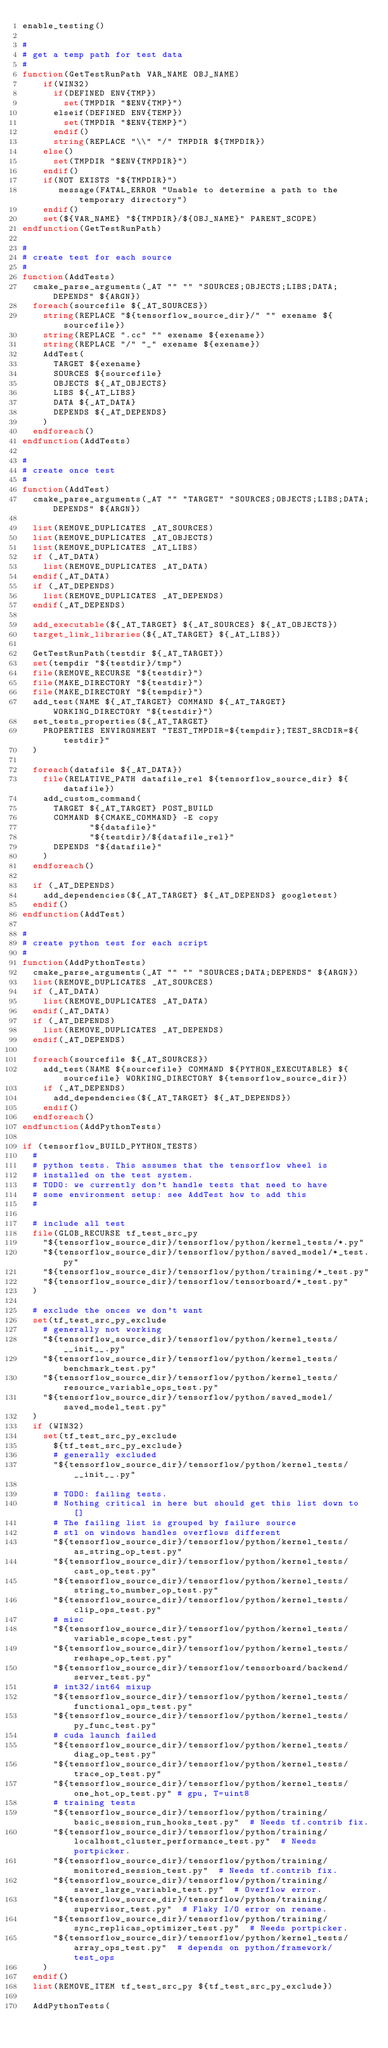<code> <loc_0><loc_0><loc_500><loc_500><_CMake_>enable_testing()

#
# get a temp path for test data
#
function(GetTestRunPath VAR_NAME OBJ_NAME)
    if(WIN32)
      if(DEFINED ENV{TMP})
        set(TMPDIR "$ENV{TMP}")
      elseif(DEFINED ENV{TEMP})
        set(TMPDIR "$ENV{TEMP}")
      endif()
      string(REPLACE "\\" "/" TMPDIR ${TMPDIR})
    else()
      set(TMPDIR "$ENV{TMPDIR}")
    endif()
    if(NOT EXISTS "${TMPDIR}")
       message(FATAL_ERROR "Unable to determine a path to the temporary directory")
    endif()
    set(${VAR_NAME} "${TMPDIR}/${OBJ_NAME}" PARENT_SCOPE)
endfunction(GetTestRunPath)

#
# create test for each source
#
function(AddTests)
  cmake_parse_arguments(_AT "" "" "SOURCES;OBJECTS;LIBS;DATA;DEPENDS" ${ARGN})
  foreach(sourcefile ${_AT_SOURCES})
    string(REPLACE "${tensorflow_source_dir}/" "" exename ${sourcefile})
    string(REPLACE ".cc" "" exename ${exename})
    string(REPLACE "/" "_" exename ${exename})
    AddTest(
      TARGET ${exename}
      SOURCES ${sourcefile}
      OBJECTS ${_AT_OBJECTS}
      LIBS ${_AT_LIBS}
      DATA ${_AT_DATA}
      DEPENDS ${_AT_DEPENDS}
    )
  endforeach()
endfunction(AddTests)

#
# create once test
#
function(AddTest)
  cmake_parse_arguments(_AT "" "TARGET" "SOURCES;OBJECTS;LIBS;DATA;DEPENDS" ${ARGN})

  list(REMOVE_DUPLICATES _AT_SOURCES)
  list(REMOVE_DUPLICATES _AT_OBJECTS)
  list(REMOVE_DUPLICATES _AT_LIBS)
  if (_AT_DATA)
    list(REMOVE_DUPLICATES _AT_DATA)
  endif(_AT_DATA)
  if (_AT_DEPENDS)
    list(REMOVE_DUPLICATES _AT_DEPENDS)
  endif(_AT_DEPENDS)

  add_executable(${_AT_TARGET} ${_AT_SOURCES} ${_AT_OBJECTS})
  target_link_libraries(${_AT_TARGET} ${_AT_LIBS})

  GetTestRunPath(testdir ${_AT_TARGET})
  set(tempdir "${testdir}/tmp")
  file(REMOVE_RECURSE "${testdir}")
  file(MAKE_DIRECTORY "${testdir}")
  file(MAKE_DIRECTORY "${tempdir}")
  add_test(NAME ${_AT_TARGET} COMMAND ${_AT_TARGET} WORKING_DIRECTORY "${testdir}")
  set_tests_properties(${_AT_TARGET}
    PROPERTIES ENVIRONMENT "TEST_TMPDIR=${tempdir};TEST_SRCDIR=${testdir}"
  )

  foreach(datafile ${_AT_DATA})
    file(RELATIVE_PATH datafile_rel ${tensorflow_source_dir} ${datafile})
    add_custom_command(
      TARGET ${_AT_TARGET} POST_BUILD
      COMMAND ${CMAKE_COMMAND} -E copy
             "${datafile}"
             "${testdir}/${datafile_rel}"
      DEPENDS "${datafile}"
    )
  endforeach()

  if (_AT_DEPENDS)
    add_dependencies(${_AT_TARGET} ${_AT_DEPENDS} googletest)
  endif()
endfunction(AddTest)

#
# create python test for each script
#
function(AddPythonTests)
  cmake_parse_arguments(_AT "" "" "SOURCES;DATA;DEPENDS" ${ARGN})
  list(REMOVE_DUPLICATES _AT_SOURCES)
  if (_AT_DATA)
    list(REMOVE_DUPLICATES _AT_DATA)
  endif(_AT_DATA)
  if (_AT_DEPENDS)
    list(REMOVE_DUPLICATES _AT_DEPENDS)
  endif(_AT_DEPENDS)

  foreach(sourcefile ${_AT_SOURCES})
    add_test(NAME ${sourcefile} COMMAND ${PYTHON_EXECUTABLE} ${sourcefile} WORKING_DIRECTORY ${tensorflow_source_dir})
    if (_AT_DEPENDS)
      add_dependencies(${_AT_TARGET} ${_AT_DEPENDS})
    endif()
  endforeach()
endfunction(AddPythonTests)

if (tensorflow_BUILD_PYTHON_TESTS)
  #
  # python tests. This assumes that the tensorflow wheel is
  # installed on the test system.
  # TODO: we currently don't handle tests that need to have
  # some environment setup: see AddTest how to add this
  #

  # include all test
  file(GLOB_RECURSE tf_test_src_py
    "${tensorflow_source_dir}/tensorflow/python/kernel_tests/*.py"
    "${tensorflow_source_dir}/tensorflow/python/saved_model/*_test.py"
    "${tensorflow_source_dir}/tensorflow/python/training/*_test.py"
    "${tensorflow_source_dir}/tensorflow/tensorboard/*_test.py"
  )

  # exclude the onces we don't want
  set(tf_test_src_py_exclude
    # generally not working
    "${tensorflow_source_dir}/tensorflow/python/kernel_tests/__init__.py"
    "${tensorflow_source_dir}/tensorflow/python/kernel_tests/benchmark_test.py"
    "${tensorflow_source_dir}/tensorflow/python/kernel_tests/resource_variable_ops_test.py"
    "${tensorflow_source_dir}/tensorflow/python/saved_model/saved_model_test.py"
  )
  if (WIN32)
    set(tf_test_src_py_exclude
      ${tf_test_src_py_exclude}
      # generally excluded
      "${tensorflow_source_dir}/tensorflow/python/kernel_tests/__init__.py"

      # TODO: failing tests.
      # Nothing critical in here but should get this list down to []
      # The failing list is grouped by failure source
      # stl on windows handles overflows different
      "${tensorflow_source_dir}/tensorflow/python/kernel_tests/as_string_op_test.py"
      "${tensorflow_source_dir}/tensorflow/python/kernel_tests/cast_op_test.py"
      "${tensorflow_source_dir}/tensorflow/python/kernel_tests/string_to_number_op_test.py"
      "${tensorflow_source_dir}/tensorflow/python/kernel_tests/clip_ops_test.py"
      # misc
      "${tensorflow_source_dir}/tensorflow/python/kernel_tests/variable_scope_test.py"
      "${tensorflow_source_dir}/tensorflow/python/kernel_tests/reshape_op_test.py"
      "${tensorflow_source_dir}/tensorflow/tensorboard/backend/server_test.py"
      # int32/int64 mixup
      "${tensorflow_source_dir}/tensorflow/python/kernel_tests/functional_ops_test.py"
      "${tensorflow_source_dir}/tensorflow/python/kernel_tests/py_func_test.py"
      # cuda launch failed
      "${tensorflow_source_dir}/tensorflow/python/kernel_tests/diag_op_test.py"
      "${tensorflow_source_dir}/tensorflow/python/kernel_tests/trace_op_test.py"
      "${tensorflow_source_dir}/tensorflow/python/kernel_tests/one_hot_op_test.py" # gpu, T=uint8
      # training tests
      "${tensorflow_source_dir}/tensorflow/python/training/basic_session_run_hooks_test.py"  # Needs tf.contrib fix.
      "${tensorflow_source_dir}/tensorflow/python/training/localhost_cluster_performance_test.py"  # Needs portpicker.
      "${tensorflow_source_dir}/tensorflow/python/training/monitored_session_test.py"  # Needs tf.contrib fix.
      "${tensorflow_source_dir}/tensorflow/python/training/saver_large_variable_test.py"  # Overflow error.
      "${tensorflow_source_dir}/tensorflow/python/training/supervisor_test.py"  # Flaky I/O error on rename.
      "${tensorflow_source_dir}/tensorflow/python/training/sync_replicas_optimizer_test.py"  # Needs portpicker.
      "${tensorflow_source_dir}/tensorflow/python/kernel_tests/array_ops_test.py"  # depends on python/framework/test_ops
    )
  endif()
  list(REMOVE_ITEM tf_test_src_py ${tf_test_src_py_exclude})

  AddPythonTests(</code> 